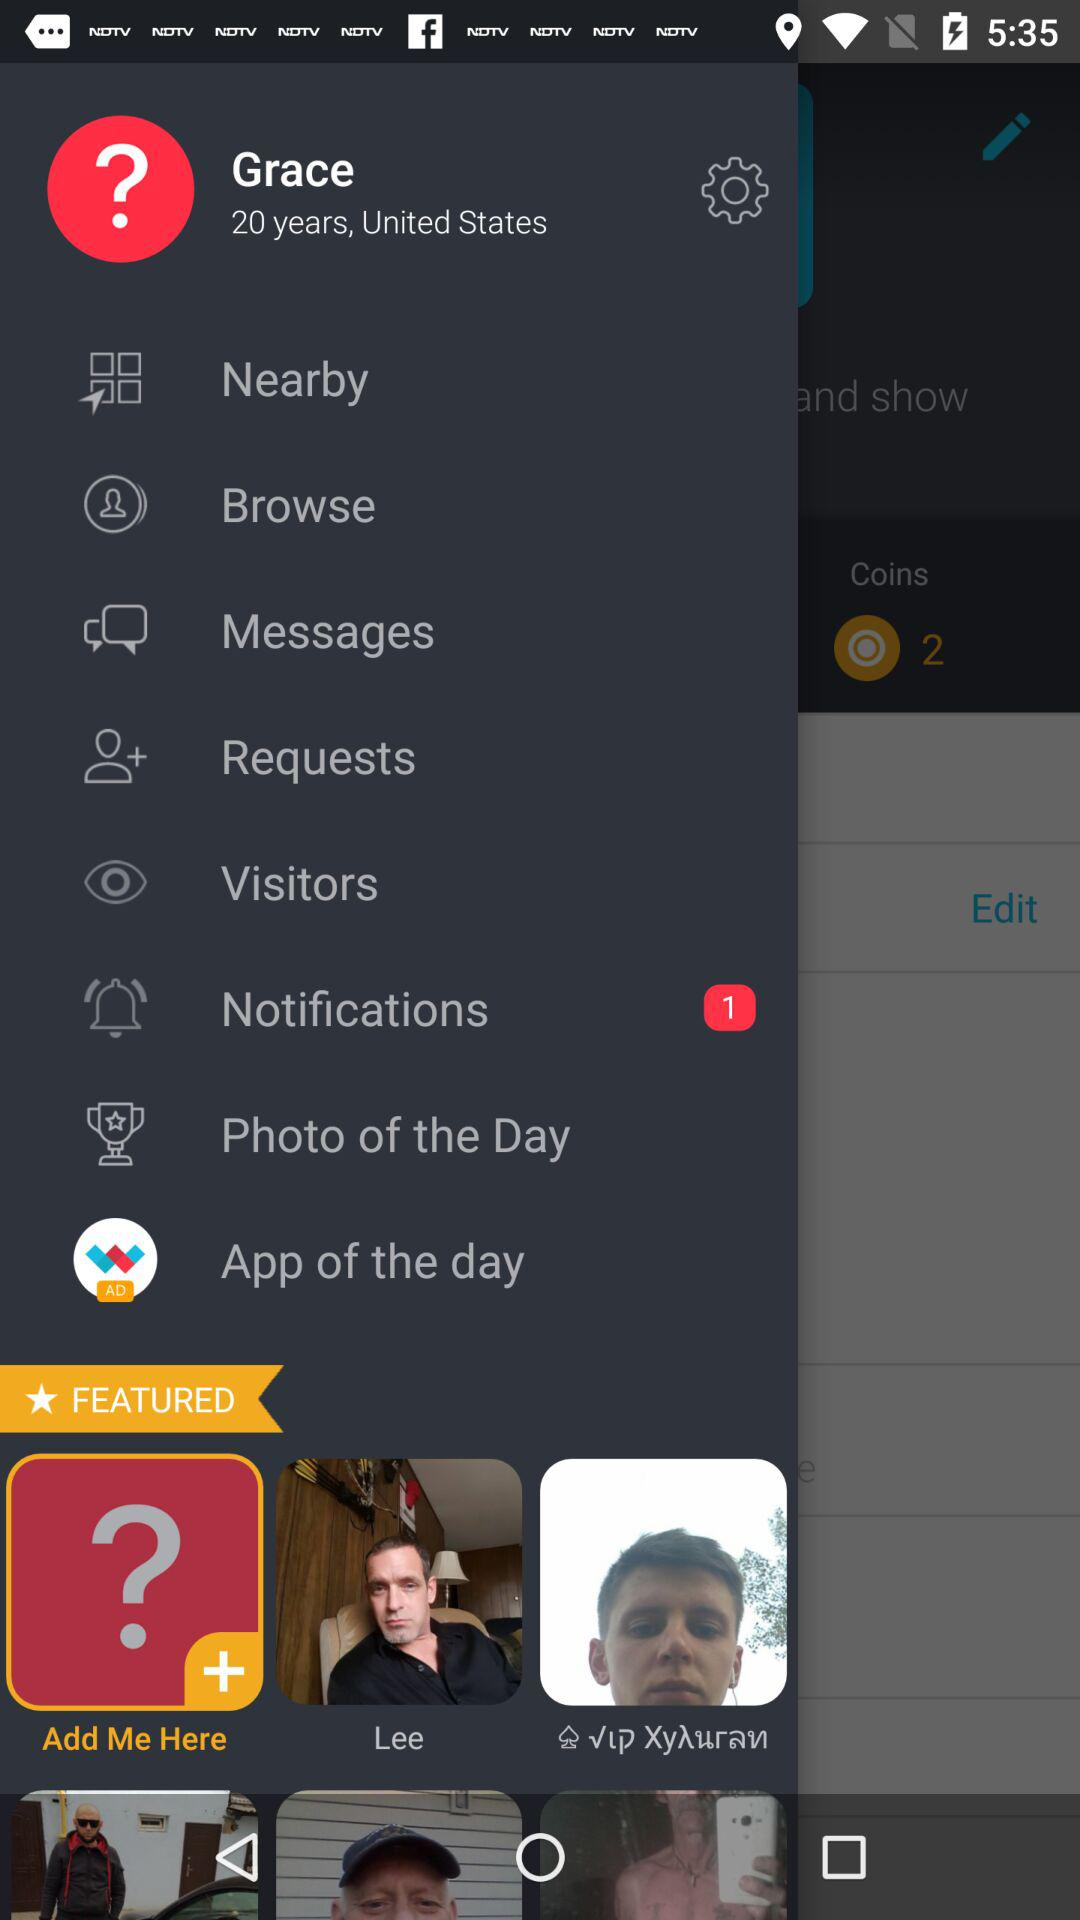How many notifications are there? There is 1 notification. 